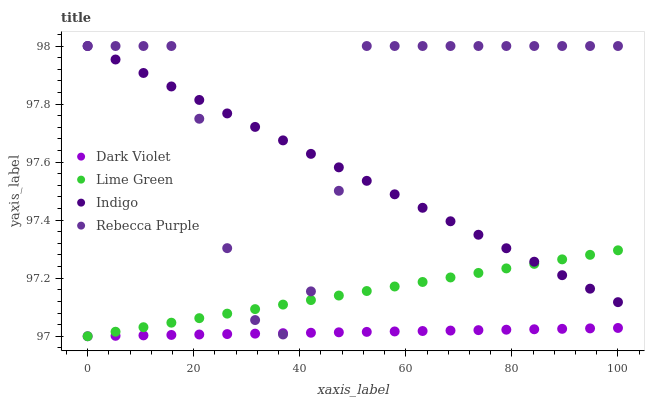Does Dark Violet have the minimum area under the curve?
Answer yes or no. Yes. Does Rebecca Purple have the maximum area under the curve?
Answer yes or no. Yes. Does Lime Green have the minimum area under the curve?
Answer yes or no. No. Does Lime Green have the maximum area under the curve?
Answer yes or no. No. Is Dark Violet the smoothest?
Answer yes or no. Yes. Is Rebecca Purple the roughest?
Answer yes or no. Yes. Is Lime Green the smoothest?
Answer yes or no. No. Is Lime Green the roughest?
Answer yes or no. No. Does Lime Green have the lowest value?
Answer yes or no. Yes. Does Rebecca Purple have the lowest value?
Answer yes or no. No. Does Rebecca Purple have the highest value?
Answer yes or no. Yes. Does Lime Green have the highest value?
Answer yes or no. No. Is Dark Violet less than Indigo?
Answer yes or no. Yes. Is Indigo greater than Dark Violet?
Answer yes or no. Yes. Does Rebecca Purple intersect Indigo?
Answer yes or no. Yes. Is Rebecca Purple less than Indigo?
Answer yes or no. No. Is Rebecca Purple greater than Indigo?
Answer yes or no. No. Does Dark Violet intersect Indigo?
Answer yes or no. No. 